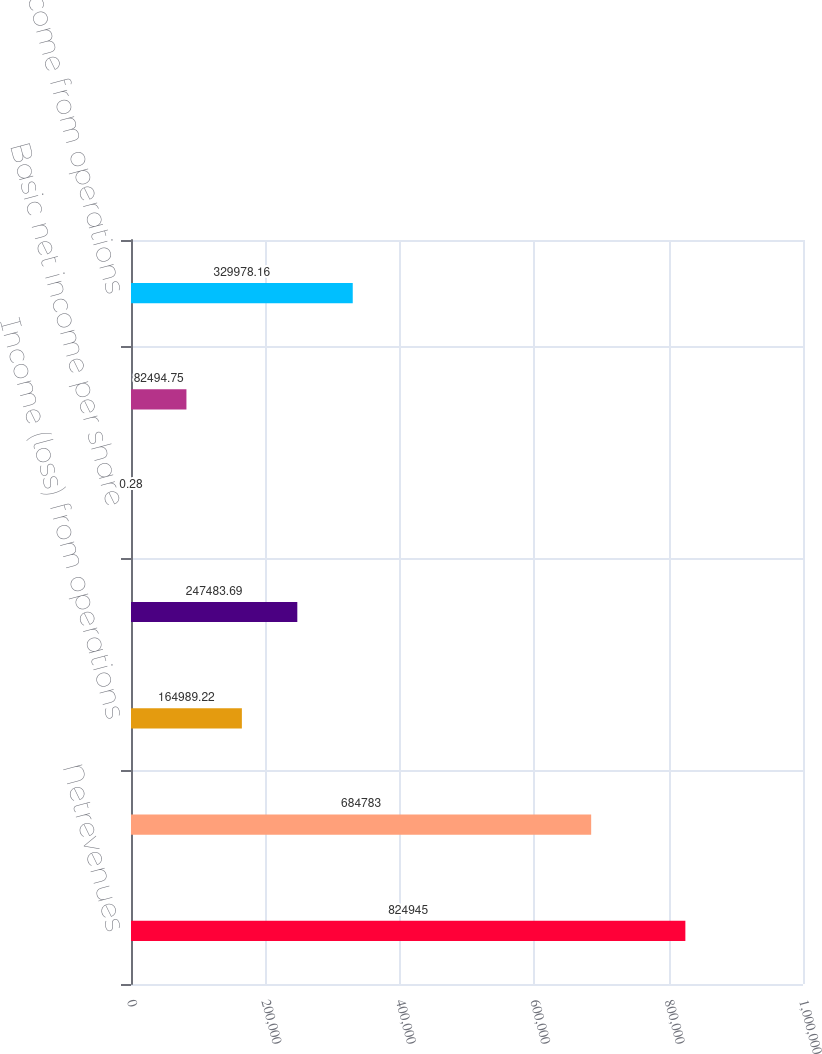Convert chart to OTSL. <chart><loc_0><loc_0><loc_500><loc_500><bar_chart><fcel>Netrevenues<fcel>Grossmargin<fcel>Income (loss) from operations<fcel>Netincome<fcel>Basic net income per share<fcel>Dilutednetincomepershare<fcel>Income from operations<nl><fcel>824945<fcel>684783<fcel>164989<fcel>247484<fcel>0.28<fcel>82494.8<fcel>329978<nl></chart> 